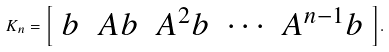<formula> <loc_0><loc_0><loc_500><loc_500>K _ { n } = { \left [ \begin{array} { l l l l l } { b } & { A b } & { A ^ { 2 } b } & { \cdots } & { A ^ { n - 1 } b } \end{array} \right ] } .</formula> 